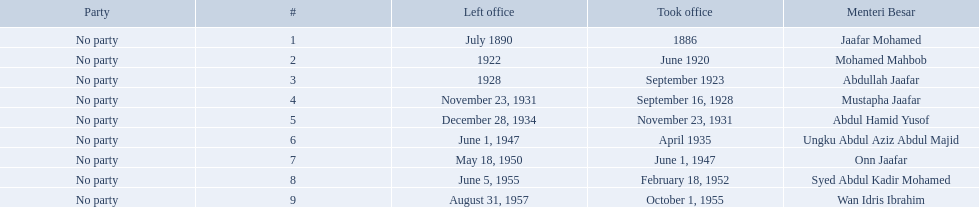Who are all of the menteri besars? Jaafar Mohamed, Mohamed Mahbob, Abdullah Jaafar, Mustapha Jaafar, Abdul Hamid Yusof, Ungku Abdul Aziz Abdul Majid, Onn Jaafar, Syed Abdul Kadir Mohamed, Wan Idris Ibrahim. When did each take office? 1886, June 1920, September 1923, September 16, 1928, November 23, 1931, April 1935, June 1, 1947, February 18, 1952, October 1, 1955. When did they leave? July 1890, 1922, 1928, November 23, 1931, December 28, 1934, June 1, 1947, May 18, 1950, June 5, 1955, August 31, 1957. And which spent the most time in office? Ungku Abdul Aziz Abdul Majid. When did jaafar mohamed take office? 1886. When did mohamed mahbob take office? June 1920. Who was in office no more than 4 years? Mohamed Mahbob. 